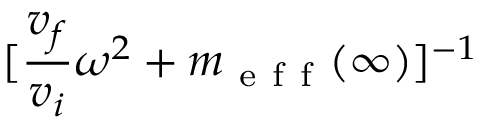Convert formula to latex. <formula><loc_0><loc_0><loc_500><loc_500>[ \frac { v _ { f } } { v _ { i } } \omega ^ { 2 } + m _ { e f f } ( \infty ) ] ^ { - 1 }</formula> 